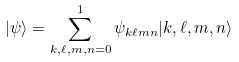<formula> <loc_0><loc_0><loc_500><loc_500>| \psi \rangle = \sum _ { k , \ell , m , n = 0 } ^ { 1 } \psi _ { k \ell m n } | k , \ell , m , n \rangle</formula> 